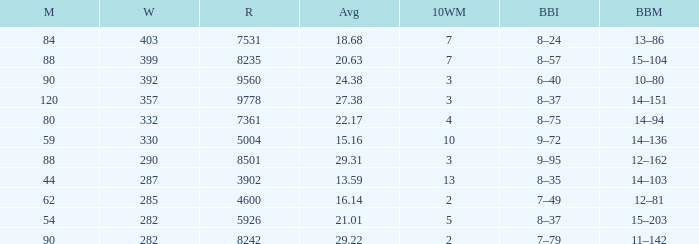What is the total number of wickets that have runs under 4600 and matches under 44? None. 